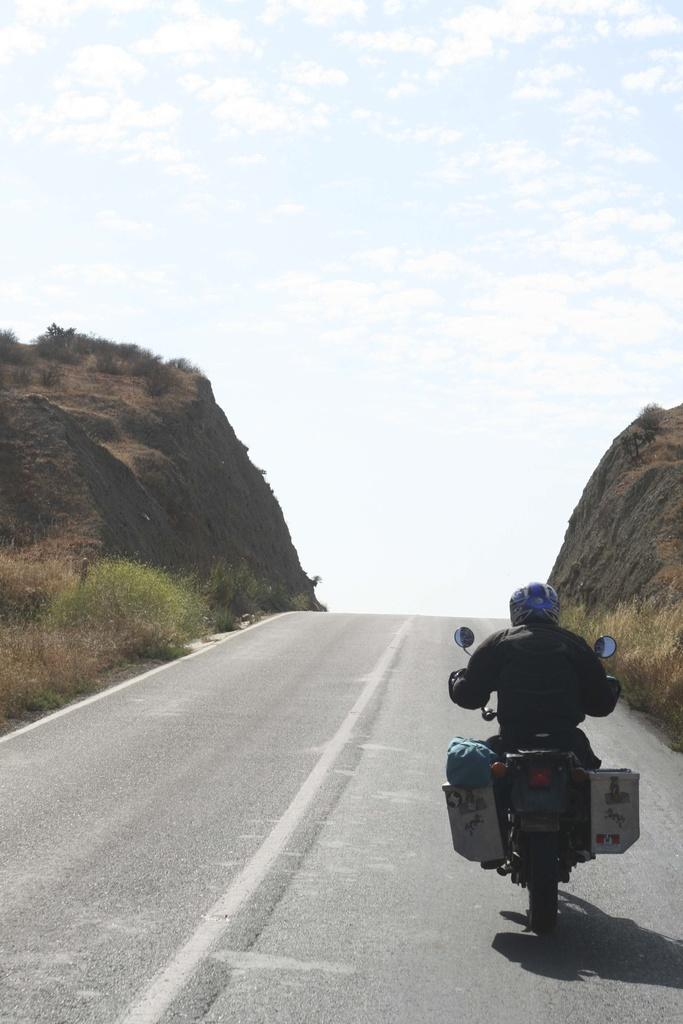What is the main subject of the image? There is a person riding a bike in the image. Where is the person riding the bike? The person is riding the bike on a road. What can be seen on both sides of the image? There are mountains on both the right and left sides of the image. What is visible in the background of the image? The sky is visible in the background of the image. What year is the government mentioned in the image? There is no mention of a government or a specific year in the image; it features a person riding a bike on a road with mountains in the background. 